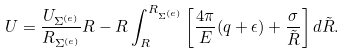<formula> <loc_0><loc_0><loc_500><loc_500>U = \frac { U _ { \Sigma ^ { ( e ) } } } { R _ { \Sigma ^ { ( e ) } } } R - R \int ^ { R _ { \Sigma ^ { ( e ) } } } _ { R } \left [ \frac { 4 \pi } { E } ( q + \epsilon ) + \frac { \sigma } { \tilde { R } } \right ] d \tilde { R } .</formula> 